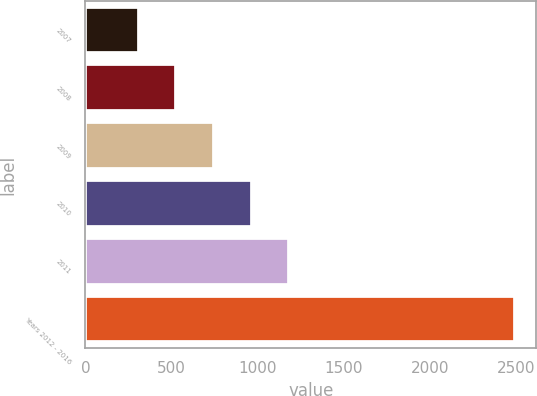Convert chart to OTSL. <chart><loc_0><loc_0><loc_500><loc_500><bar_chart><fcel>2007<fcel>2008<fcel>2009<fcel>2010<fcel>2011<fcel>Years 2012 - 2016<nl><fcel>309<fcel>527.4<fcel>745.8<fcel>964.2<fcel>1182.6<fcel>2493<nl></chart> 